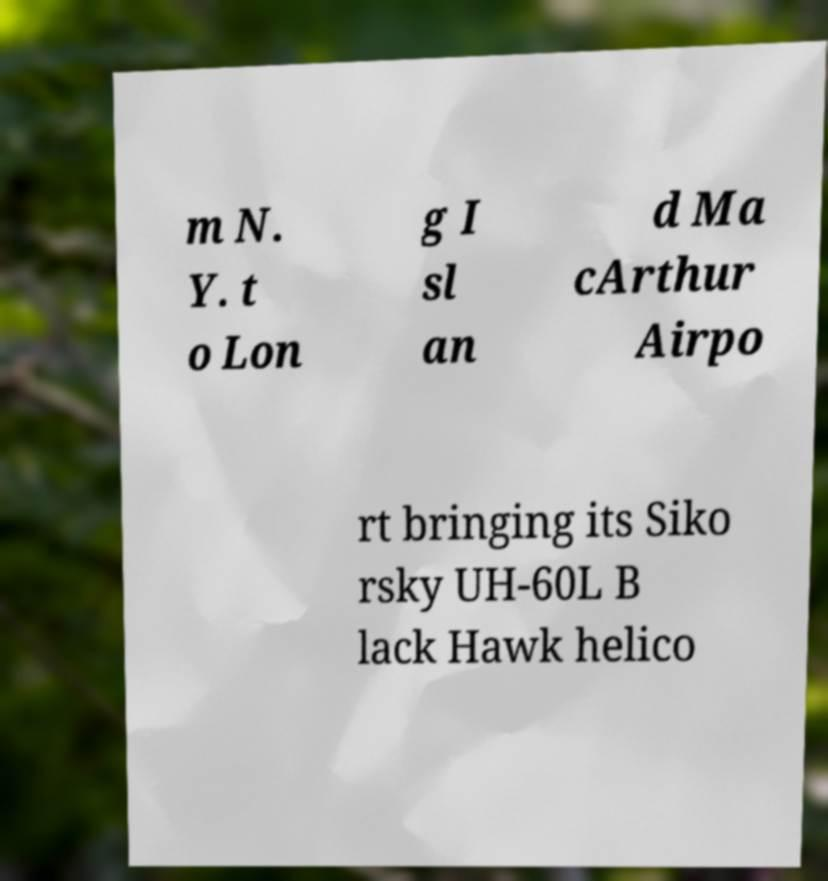I need the written content from this picture converted into text. Can you do that? m N. Y. t o Lon g I sl an d Ma cArthur Airpo rt bringing its Siko rsky UH-60L B lack Hawk helico 